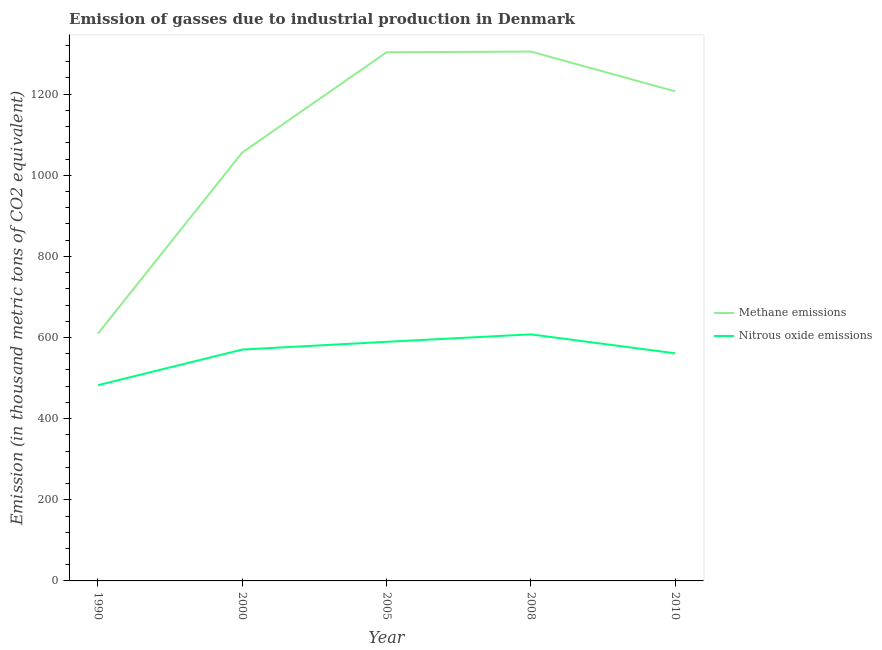Does the line corresponding to amount of methane emissions intersect with the line corresponding to amount of nitrous oxide emissions?
Provide a succinct answer. No. Is the number of lines equal to the number of legend labels?
Ensure brevity in your answer.  Yes. What is the amount of methane emissions in 1990?
Ensure brevity in your answer.  609.7. Across all years, what is the maximum amount of methane emissions?
Provide a succinct answer. 1304.9. Across all years, what is the minimum amount of methane emissions?
Your answer should be very brief. 609.7. In which year was the amount of methane emissions minimum?
Your answer should be compact. 1990. What is the total amount of nitrous oxide emissions in the graph?
Make the answer very short. 2811.1. What is the difference between the amount of methane emissions in 2000 and that in 2010?
Keep it short and to the point. -150.8. What is the difference between the amount of methane emissions in 2005 and the amount of nitrous oxide emissions in 1990?
Give a very brief answer. 820.6. What is the average amount of methane emissions per year?
Offer a very short reply. 1096.1. In the year 2005, what is the difference between the amount of methane emissions and amount of nitrous oxide emissions?
Make the answer very short. 713.7. What is the ratio of the amount of methane emissions in 2005 to that in 2008?
Your response must be concise. 1. Is the amount of nitrous oxide emissions in 2008 less than that in 2010?
Provide a succinct answer. No. What is the difference between the highest and the second highest amount of nitrous oxide emissions?
Keep it short and to the point. 18.4. What is the difference between the highest and the lowest amount of methane emissions?
Make the answer very short. 695.2. In how many years, is the amount of nitrous oxide emissions greater than the average amount of nitrous oxide emissions taken over all years?
Keep it short and to the point. 3. Is the amount of nitrous oxide emissions strictly greater than the amount of methane emissions over the years?
Provide a short and direct response. No. Is the amount of methane emissions strictly less than the amount of nitrous oxide emissions over the years?
Make the answer very short. No. How many years are there in the graph?
Your response must be concise. 5. What is the difference between two consecutive major ticks on the Y-axis?
Give a very brief answer. 200. Where does the legend appear in the graph?
Keep it short and to the point. Center right. How many legend labels are there?
Your answer should be very brief. 2. How are the legend labels stacked?
Ensure brevity in your answer.  Vertical. What is the title of the graph?
Ensure brevity in your answer.  Emission of gasses due to industrial production in Denmark. Does "ODA received" appear as one of the legend labels in the graph?
Provide a succinct answer. No. What is the label or title of the Y-axis?
Your response must be concise. Emission (in thousand metric tons of CO2 equivalent). What is the Emission (in thousand metric tons of CO2 equivalent) of Methane emissions in 1990?
Keep it short and to the point. 609.7. What is the Emission (in thousand metric tons of CO2 equivalent) in Nitrous oxide emissions in 1990?
Your answer should be very brief. 482.5. What is the Emission (in thousand metric tons of CO2 equivalent) of Methane emissions in 2000?
Give a very brief answer. 1056. What is the Emission (in thousand metric tons of CO2 equivalent) in Nitrous oxide emissions in 2000?
Give a very brief answer. 570.3. What is the Emission (in thousand metric tons of CO2 equivalent) in Methane emissions in 2005?
Keep it short and to the point. 1303.1. What is the Emission (in thousand metric tons of CO2 equivalent) in Nitrous oxide emissions in 2005?
Provide a short and direct response. 589.4. What is the Emission (in thousand metric tons of CO2 equivalent) in Methane emissions in 2008?
Your answer should be very brief. 1304.9. What is the Emission (in thousand metric tons of CO2 equivalent) in Nitrous oxide emissions in 2008?
Make the answer very short. 607.8. What is the Emission (in thousand metric tons of CO2 equivalent) of Methane emissions in 2010?
Provide a short and direct response. 1206.8. What is the Emission (in thousand metric tons of CO2 equivalent) of Nitrous oxide emissions in 2010?
Make the answer very short. 561.1. Across all years, what is the maximum Emission (in thousand metric tons of CO2 equivalent) in Methane emissions?
Offer a terse response. 1304.9. Across all years, what is the maximum Emission (in thousand metric tons of CO2 equivalent) in Nitrous oxide emissions?
Your answer should be compact. 607.8. Across all years, what is the minimum Emission (in thousand metric tons of CO2 equivalent) of Methane emissions?
Provide a short and direct response. 609.7. Across all years, what is the minimum Emission (in thousand metric tons of CO2 equivalent) in Nitrous oxide emissions?
Provide a short and direct response. 482.5. What is the total Emission (in thousand metric tons of CO2 equivalent) in Methane emissions in the graph?
Your response must be concise. 5480.5. What is the total Emission (in thousand metric tons of CO2 equivalent) in Nitrous oxide emissions in the graph?
Your answer should be compact. 2811.1. What is the difference between the Emission (in thousand metric tons of CO2 equivalent) in Methane emissions in 1990 and that in 2000?
Your answer should be compact. -446.3. What is the difference between the Emission (in thousand metric tons of CO2 equivalent) of Nitrous oxide emissions in 1990 and that in 2000?
Give a very brief answer. -87.8. What is the difference between the Emission (in thousand metric tons of CO2 equivalent) of Methane emissions in 1990 and that in 2005?
Keep it short and to the point. -693.4. What is the difference between the Emission (in thousand metric tons of CO2 equivalent) in Nitrous oxide emissions in 1990 and that in 2005?
Make the answer very short. -106.9. What is the difference between the Emission (in thousand metric tons of CO2 equivalent) in Methane emissions in 1990 and that in 2008?
Make the answer very short. -695.2. What is the difference between the Emission (in thousand metric tons of CO2 equivalent) of Nitrous oxide emissions in 1990 and that in 2008?
Your answer should be compact. -125.3. What is the difference between the Emission (in thousand metric tons of CO2 equivalent) of Methane emissions in 1990 and that in 2010?
Your answer should be compact. -597.1. What is the difference between the Emission (in thousand metric tons of CO2 equivalent) of Nitrous oxide emissions in 1990 and that in 2010?
Your answer should be very brief. -78.6. What is the difference between the Emission (in thousand metric tons of CO2 equivalent) of Methane emissions in 2000 and that in 2005?
Ensure brevity in your answer.  -247.1. What is the difference between the Emission (in thousand metric tons of CO2 equivalent) of Nitrous oxide emissions in 2000 and that in 2005?
Ensure brevity in your answer.  -19.1. What is the difference between the Emission (in thousand metric tons of CO2 equivalent) in Methane emissions in 2000 and that in 2008?
Keep it short and to the point. -248.9. What is the difference between the Emission (in thousand metric tons of CO2 equivalent) of Nitrous oxide emissions in 2000 and that in 2008?
Your answer should be compact. -37.5. What is the difference between the Emission (in thousand metric tons of CO2 equivalent) in Methane emissions in 2000 and that in 2010?
Offer a terse response. -150.8. What is the difference between the Emission (in thousand metric tons of CO2 equivalent) of Methane emissions in 2005 and that in 2008?
Give a very brief answer. -1.8. What is the difference between the Emission (in thousand metric tons of CO2 equivalent) in Nitrous oxide emissions in 2005 and that in 2008?
Ensure brevity in your answer.  -18.4. What is the difference between the Emission (in thousand metric tons of CO2 equivalent) in Methane emissions in 2005 and that in 2010?
Your answer should be compact. 96.3. What is the difference between the Emission (in thousand metric tons of CO2 equivalent) in Nitrous oxide emissions in 2005 and that in 2010?
Provide a succinct answer. 28.3. What is the difference between the Emission (in thousand metric tons of CO2 equivalent) of Methane emissions in 2008 and that in 2010?
Provide a short and direct response. 98.1. What is the difference between the Emission (in thousand metric tons of CO2 equivalent) of Nitrous oxide emissions in 2008 and that in 2010?
Keep it short and to the point. 46.7. What is the difference between the Emission (in thousand metric tons of CO2 equivalent) in Methane emissions in 1990 and the Emission (in thousand metric tons of CO2 equivalent) in Nitrous oxide emissions in 2000?
Ensure brevity in your answer.  39.4. What is the difference between the Emission (in thousand metric tons of CO2 equivalent) in Methane emissions in 1990 and the Emission (in thousand metric tons of CO2 equivalent) in Nitrous oxide emissions in 2005?
Keep it short and to the point. 20.3. What is the difference between the Emission (in thousand metric tons of CO2 equivalent) of Methane emissions in 1990 and the Emission (in thousand metric tons of CO2 equivalent) of Nitrous oxide emissions in 2008?
Keep it short and to the point. 1.9. What is the difference between the Emission (in thousand metric tons of CO2 equivalent) of Methane emissions in 1990 and the Emission (in thousand metric tons of CO2 equivalent) of Nitrous oxide emissions in 2010?
Your response must be concise. 48.6. What is the difference between the Emission (in thousand metric tons of CO2 equivalent) of Methane emissions in 2000 and the Emission (in thousand metric tons of CO2 equivalent) of Nitrous oxide emissions in 2005?
Your response must be concise. 466.6. What is the difference between the Emission (in thousand metric tons of CO2 equivalent) of Methane emissions in 2000 and the Emission (in thousand metric tons of CO2 equivalent) of Nitrous oxide emissions in 2008?
Provide a short and direct response. 448.2. What is the difference between the Emission (in thousand metric tons of CO2 equivalent) of Methane emissions in 2000 and the Emission (in thousand metric tons of CO2 equivalent) of Nitrous oxide emissions in 2010?
Make the answer very short. 494.9. What is the difference between the Emission (in thousand metric tons of CO2 equivalent) of Methane emissions in 2005 and the Emission (in thousand metric tons of CO2 equivalent) of Nitrous oxide emissions in 2008?
Your answer should be very brief. 695.3. What is the difference between the Emission (in thousand metric tons of CO2 equivalent) of Methane emissions in 2005 and the Emission (in thousand metric tons of CO2 equivalent) of Nitrous oxide emissions in 2010?
Make the answer very short. 742. What is the difference between the Emission (in thousand metric tons of CO2 equivalent) of Methane emissions in 2008 and the Emission (in thousand metric tons of CO2 equivalent) of Nitrous oxide emissions in 2010?
Your answer should be compact. 743.8. What is the average Emission (in thousand metric tons of CO2 equivalent) of Methane emissions per year?
Keep it short and to the point. 1096.1. What is the average Emission (in thousand metric tons of CO2 equivalent) in Nitrous oxide emissions per year?
Provide a succinct answer. 562.22. In the year 1990, what is the difference between the Emission (in thousand metric tons of CO2 equivalent) of Methane emissions and Emission (in thousand metric tons of CO2 equivalent) of Nitrous oxide emissions?
Ensure brevity in your answer.  127.2. In the year 2000, what is the difference between the Emission (in thousand metric tons of CO2 equivalent) of Methane emissions and Emission (in thousand metric tons of CO2 equivalent) of Nitrous oxide emissions?
Make the answer very short. 485.7. In the year 2005, what is the difference between the Emission (in thousand metric tons of CO2 equivalent) in Methane emissions and Emission (in thousand metric tons of CO2 equivalent) in Nitrous oxide emissions?
Keep it short and to the point. 713.7. In the year 2008, what is the difference between the Emission (in thousand metric tons of CO2 equivalent) in Methane emissions and Emission (in thousand metric tons of CO2 equivalent) in Nitrous oxide emissions?
Keep it short and to the point. 697.1. In the year 2010, what is the difference between the Emission (in thousand metric tons of CO2 equivalent) of Methane emissions and Emission (in thousand metric tons of CO2 equivalent) of Nitrous oxide emissions?
Provide a short and direct response. 645.7. What is the ratio of the Emission (in thousand metric tons of CO2 equivalent) in Methane emissions in 1990 to that in 2000?
Your response must be concise. 0.58. What is the ratio of the Emission (in thousand metric tons of CO2 equivalent) of Nitrous oxide emissions in 1990 to that in 2000?
Give a very brief answer. 0.85. What is the ratio of the Emission (in thousand metric tons of CO2 equivalent) of Methane emissions in 1990 to that in 2005?
Provide a short and direct response. 0.47. What is the ratio of the Emission (in thousand metric tons of CO2 equivalent) of Nitrous oxide emissions in 1990 to that in 2005?
Give a very brief answer. 0.82. What is the ratio of the Emission (in thousand metric tons of CO2 equivalent) of Methane emissions in 1990 to that in 2008?
Your response must be concise. 0.47. What is the ratio of the Emission (in thousand metric tons of CO2 equivalent) of Nitrous oxide emissions in 1990 to that in 2008?
Your answer should be very brief. 0.79. What is the ratio of the Emission (in thousand metric tons of CO2 equivalent) of Methane emissions in 1990 to that in 2010?
Provide a short and direct response. 0.51. What is the ratio of the Emission (in thousand metric tons of CO2 equivalent) in Nitrous oxide emissions in 1990 to that in 2010?
Make the answer very short. 0.86. What is the ratio of the Emission (in thousand metric tons of CO2 equivalent) of Methane emissions in 2000 to that in 2005?
Your answer should be very brief. 0.81. What is the ratio of the Emission (in thousand metric tons of CO2 equivalent) in Nitrous oxide emissions in 2000 to that in 2005?
Provide a short and direct response. 0.97. What is the ratio of the Emission (in thousand metric tons of CO2 equivalent) in Methane emissions in 2000 to that in 2008?
Provide a short and direct response. 0.81. What is the ratio of the Emission (in thousand metric tons of CO2 equivalent) in Nitrous oxide emissions in 2000 to that in 2008?
Provide a short and direct response. 0.94. What is the ratio of the Emission (in thousand metric tons of CO2 equivalent) of Methane emissions in 2000 to that in 2010?
Provide a short and direct response. 0.88. What is the ratio of the Emission (in thousand metric tons of CO2 equivalent) of Nitrous oxide emissions in 2000 to that in 2010?
Ensure brevity in your answer.  1.02. What is the ratio of the Emission (in thousand metric tons of CO2 equivalent) in Methane emissions in 2005 to that in 2008?
Your response must be concise. 1. What is the ratio of the Emission (in thousand metric tons of CO2 equivalent) of Nitrous oxide emissions in 2005 to that in 2008?
Ensure brevity in your answer.  0.97. What is the ratio of the Emission (in thousand metric tons of CO2 equivalent) of Methane emissions in 2005 to that in 2010?
Provide a short and direct response. 1.08. What is the ratio of the Emission (in thousand metric tons of CO2 equivalent) of Nitrous oxide emissions in 2005 to that in 2010?
Give a very brief answer. 1.05. What is the ratio of the Emission (in thousand metric tons of CO2 equivalent) in Methane emissions in 2008 to that in 2010?
Your answer should be very brief. 1.08. What is the ratio of the Emission (in thousand metric tons of CO2 equivalent) in Nitrous oxide emissions in 2008 to that in 2010?
Offer a very short reply. 1.08. What is the difference between the highest and the second highest Emission (in thousand metric tons of CO2 equivalent) of Methane emissions?
Offer a terse response. 1.8. What is the difference between the highest and the second highest Emission (in thousand metric tons of CO2 equivalent) of Nitrous oxide emissions?
Give a very brief answer. 18.4. What is the difference between the highest and the lowest Emission (in thousand metric tons of CO2 equivalent) in Methane emissions?
Ensure brevity in your answer.  695.2. What is the difference between the highest and the lowest Emission (in thousand metric tons of CO2 equivalent) in Nitrous oxide emissions?
Give a very brief answer. 125.3. 